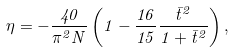<formula> <loc_0><loc_0><loc_500><loc_500>\eta = - \frac { 4 0 } { \pi ^ { 2 } N } \left ( 1 - \frac { 1 6 } { 1 5 } \frac { \bar { t } ^ { 2 } } { 1 + \bar { t } ^ { 2 } } \right ) ,</formula> 